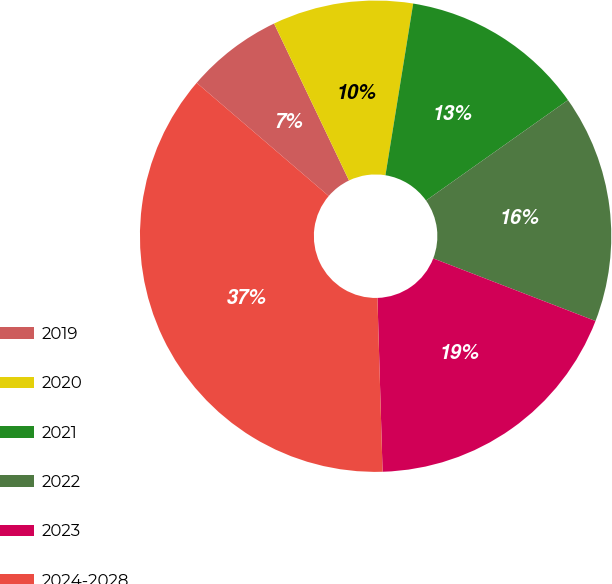<chart> <loc_0><loc_0><loc_500><loc_500><pie_chart><fcel>2019<fcel>2020<fcel>2021<fcel>2022<fcel>2023<fcel>2024-2028<nl><fcel>6.63%<fcel>9.64%<fcel>12.65%<fcel>15.66%<fcel>18.67%<fcel>36.75%<nl></chart> 